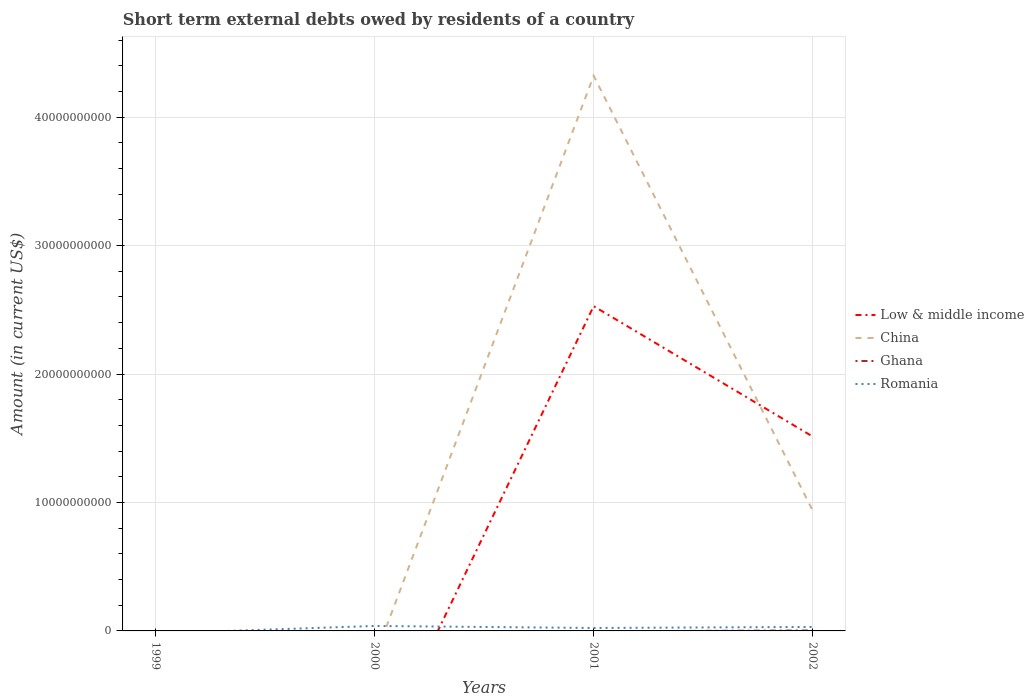Does the line corresponding to Romania intersect with the line corresponding to Low & middle income?
Make the answer very short. Yes. Is the number of lines equal to the number of legend labels?
Your answer should be compact. No. What is the total amount of short-term external debts owed by residents in China in the graph?
Offer a terse response. 3.38e+1. What is the difference between the highest and the second highest amount of short-term external debts owed by residents in Low & middle income?
Your answer should be compact. 2.53e+1. What is the difference between the highest and the lowest amount of short-term external debts owed by residents in Romania?
Provide a short and direct response. 2. Is the amount of short-term external debts owed by residents in Romania strictly greater than the amount of short-term external debts owed by residents in Ghana over the years?
Give a very brief answer. No. How many lines are there?
Your answer should be compact. 4. Are the values on the major ticks of Y-axis written in scientific E-notation?
Ensure brevity in your answer.  No. Does the graph contain grids?
Provide a succinct answer. Yes. What is the title of the graph?
Provide a short and direct response. Short term external debts owed by residents of a country. Does "Uganda" appear as one of the legend labels in the graph?
Offer a very short reply. No. What is the label or title of the X-axis?
Your answer should be very brief. Years. What is the Amount (in current US$) in Ghana in 1999?
Provide a short and direct response. 0. What is the Amount (in current US$) in China in 2000?
Offer a terse response. 0. What is the Amount (in current US$) of Romania in 2000?
Offer a terse response. 3.86e+08. What is the Amount (in current US$) in Low & middle income in 2001?
Keep it short and to the point. 2.53e+1. What is the Amount (in current US$) of China in 2001?
Make the answer very short. 4.32e+1. What is the Amount (in current US$) in Romania in 2001?
Make the answer very short. 2.29e+08. What is the Amount (in current US$) of Low & middle income in 2002?
Keep it short and to the point. 1.51e+1. What is the Amount (in current US$) in China in 2002?
Ensure brevity in your answer.  9.38e+09. What is the Amount (in current US$) of Ghana in 2002?
Give a very brief answer. 3.44e+07. What is the Amount (in current US$) in Romania in 2002?
Your response must be concise. 3.10e+08. Across all years, what is the maximum Amount (in current US$) of Low & middle income?
Provide a short and direct response. 2.53e+1. Across all years, what is the maximum Amount (in current US$) of China?
Make the answer very short. 4.32e+1. Across all years, what is the maximum Amount (in current US$) in Ghana?
Make the answer very short. 3.44e+07. Across all years, what is the maximum Amount (in current US$) in Romania?
Your answer should be very brief. 3.86e+08. What is the total Amount (in current US$) in Low & middle income in the graph?
Make the answer very short. 4.04e+1. What is the total Amount (in current US$) in China in the graph?
Ensure brevity in your answer.  5.26e+1. What is the total Amount (in current US$) of Ghana in the graph?
Give a very brief answer. 3.44e+07. What is the total Amount (in current US$) in Romania in the graph?
Keep it short and to the point. 9.25e+08. What is the difference between the Amount (in current US$) of Romania in 2000 and that in 2001?
Your answer should be compact. 1.57e+08. What is the difference between the Amount (in current US$) in Romania in 2000 and that in 2002?
Give a very brief answer. 7.54e+07. What is the difference between the Amount (in current US$) of Low & middle income in 2001 and that in 2002?
Your response must be concise. 1.01e+1. What is the difference between the Amount (in current US$) of China in 2001 and that in 2002?
Offer a very short reply. 3.38e+1. What is the difference between the Amount (in current US$) of Romania in 2001 and that in 2002?
Keep it short and to the point. -8.13e+07. What is the difference between the Amount (in current US$) in Low & middle income in 2001 and the Amount (in current US$) in China in 2002?
Offer a terse response. 1.59e+1. What is the difference between the Amount (in current US$) in Low & middle income in 2001 and the Amount (in current US$) in Ghana in 2002?
Ensure brevity in your answer.  2.52e+1. What is the difference between the Amount (in current US$) in Low & middle income in 2001 and the Amount (in current US$) in Romania in 2002?
Your answer should be very brief. 2.50e+1. What is the difference between the Amount (in current US$) of China in 2001 and the Amount (in current US$) of Ghana in 2002?
Your answer should be compact. 4.32e+1. What is the difference between the Amount (in current US$) of China in 2001 and the Amount (in current US$) of Romania in 2002?
Give a very brief answer. 4.29e+1. What is the average Amount (in current US$) in Low & middle income per year?
Keep it short and to the point. 1.01e+1. What is the average Amount (in current US$) of China per year?
Offer a terse response. 1.32e+1. What is the average Amount (in current US$) of Ghana per year?
Keep it short and to the point. 8.59e+06. What is the average Amount (in current US$) of Romania per year?
Ensure brevity in your answer.  2.31e+08. In the year 2001, what is the difference between the Amount (in current US$) of Low & middle income and Amount (in current US$) of China?
Provide a short and direct response. -1.79e+1. In the year 2001, what is the difference between the Amount (in current US$) in Low & middle income and Amount (in current US$) in Romania?
Make the answer very short. 2.51e+1. In the year 2001, what is the difference between the Amount (in current US$) of China and Amount (in current US$) of Romania?
Your answer should be very brief. 4.30e+1. In the year 2002, what is the difference between the Amount (in current US$) of Low & middle income and Amount (in current US$) of China?
Offer a terse response. 5.76e+09. In the year 2002, what is the difference between the Amount (in current US$) of Low & middle income and Amount (in current US$) of Ghana?
Keep it short and to the point. 1.51e+1. In the year 2002, what is the difference between the Amount (in current US$) in Low & middle income and Amount (in current US$) in Romania?
Provide a short and direct response. 1.48e+1. In the year 2002, what is the difference between the Amount (in current US$) of China and Amount (in current US$) of Ghana?
Make the answer very short. 9.35e+09. In the year 2002, what is the difference between the Amount (in current US$) of China and Amount (in current US$) of Romania?
Provide a succinct answer. 9.07e+09. In the year 2002, what is the difference between the Amount (in current US$) in Ghana and Amount (in current US$) in Romania?
Offer a very short reply. -2.76e+08. What is the ratio of the Amount (in current US$) of Romania in 2000 to that in 2001?
Your answer should be very brief. 1.68. What is the ratio of the Amount (in current US$) in Romania in 2000 to that in 2002?
Keep it short and to the point. 1.24. What is the ratio of the Amount (in current US$) of Low & middle income in 2001 to that in 2002?
Give a very brief answer. 1.67. What is the ratio of the Amount (in current US$) in China in 2001 to that in 2002?
Offer a very short reply. 4.61. What is the ratio of the Amount (in current US$) of Romania in 2001 to that in 2002?
Keep it short and to the point. 0.74. What is the difference between the highest and the second highest Amount (in current US$) in Romania?
Ensure brevity in your answer.  7.54e+07. What is the difference between the highest and the lowest Amount (in current US$) of Low & middle income?
Your answer should be very brief. 2.53e+1. What is the difference between the highest and the lowest Amount (in current US$) of China?
Provide a succinct answer. 4.32e+1. What is the difference between the highest and the lowest Amount (in current US$) of Ghana?
Ensure brevity in your answer.  3.44e+07. What is the difference between the highest and the lowest Amount (in current US$) of Romania?
Make the answer very short. 3.86e+08. 